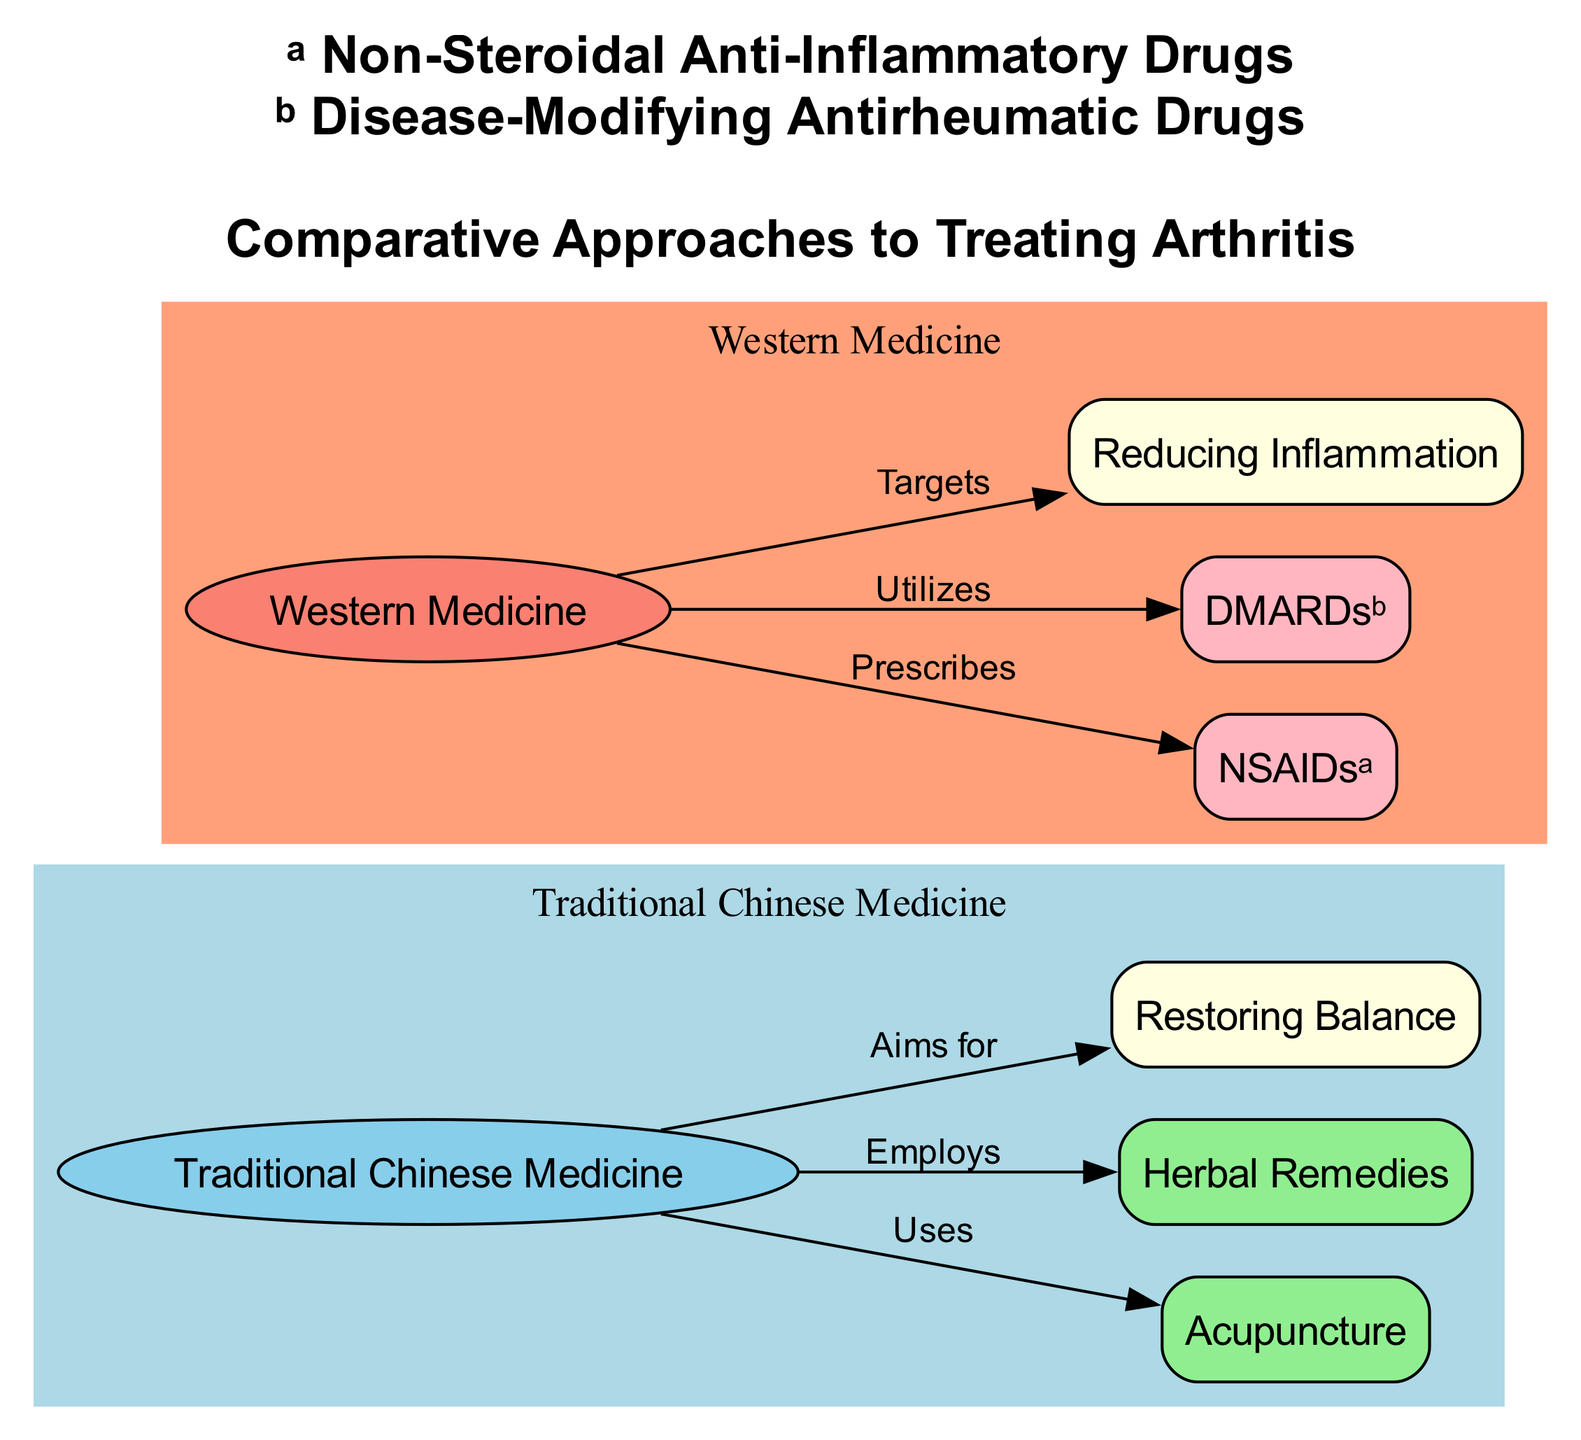What is the aim of Traditional Chinese Medicine in treating arthritis? The diagram shows that Traditional Chinese Medicine aims for "Restoring Balance," which is directly connected as a goal node to the TCM node.
Answer: Restoring Balance What remedy type does Traditional Chinese Medicine employ? The diagram indicates that Traditional Chinese Medicine employs "Herbal Remedies," which is one of the nodes associated with the TCM node in the diagram.
Answer: Herbal Remedies How many nodes represent the approaches in treating arthritis? By counting the distinct nodes in the diagram, we see there are a total of eight nodes, representing different approaches and treatments in both Traditional Chinese Medicine and Western Medicine.
Answer: Eight Which medication type does Western Medicine prescribe for arthritis? The diagram specifies that Western Medicine prescribes "NSAIDs," marking a direct connection from the Western Medicine node to the NSAIDs node.
Answer: NSAIDs What is one primary focus of Western Medicine in treating arthritis? The relationship in the diagram indicates that Western Medicine targets "Reducing Inflammation," which is highlighted as a primary focus connected to the Western Medicine node.
Answer: Reducing Inflammation What practices are included under Traditional Chinese Medicine? The diagram lists "Acupuncture" and "Herbal Remedies" as part of Traditional Chinese Medicine practices, demonstrating a connection from the TCM node to both treatment methods.
Answer: Acupuncture and Herbal Remedies Which category of drugs does Western Medicine utilize specifically for arthritis? The diagram outlines that Western Medicine utilizes "DMARDs," which refers to Disease-Modifying Antirheumatic Drugs, showing a direct connection to the Western Medicine node.
Answer: DMARDs How do the aims of Traditional Chinese Medicine and Western Medicine differ, according to the diagram? The diagram suggests that Traditional Chinese Medicine aims for the holistic goal of "Restoring Balance," whereas Western Medicine's focus is primarily on "Reducing Inflammation." This contrast highlights their differing approaches in treating arthritis.
Answer: Restoring Balance vs. Reducing Inflammation What is the connection between acupuncture and Traditional Chinese Medicine? The diagram explicitly illustrates that acupuncture is a practice that Traditional Chinese Medicine "Uses," creating a direct edge between the TCM node and acupuncture node.
Answer: Uses 